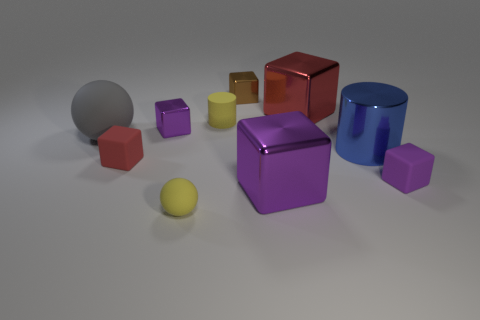Subtract all gray balls. How many purple cubes are left? 3 Subtract all red cubes. How many cubes are left? 4 Subtract all matte cubes. How many cubes are left? 4 Subtract 2 blocks. How many blocks are left? 4 Subtract all blue blocks. Subtract all brown balls. How many blocks are left? 6 Subtract all cylinders. How many objects are left? 8 Subtract all big gray balls. Subtract all big blue objects. How many objects are left? 8 Add 7 large red metal cubes. How many large red metal cubes are left? 8 Add 8 tiny yellow cylinders. How many tiny yellow cylinders exist? 9 Subtract 0 green cylinders. How many objects are left? 10 